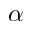<formula> <loc_0><loc_0><loc_500><loc_500>\alpha</formula> 